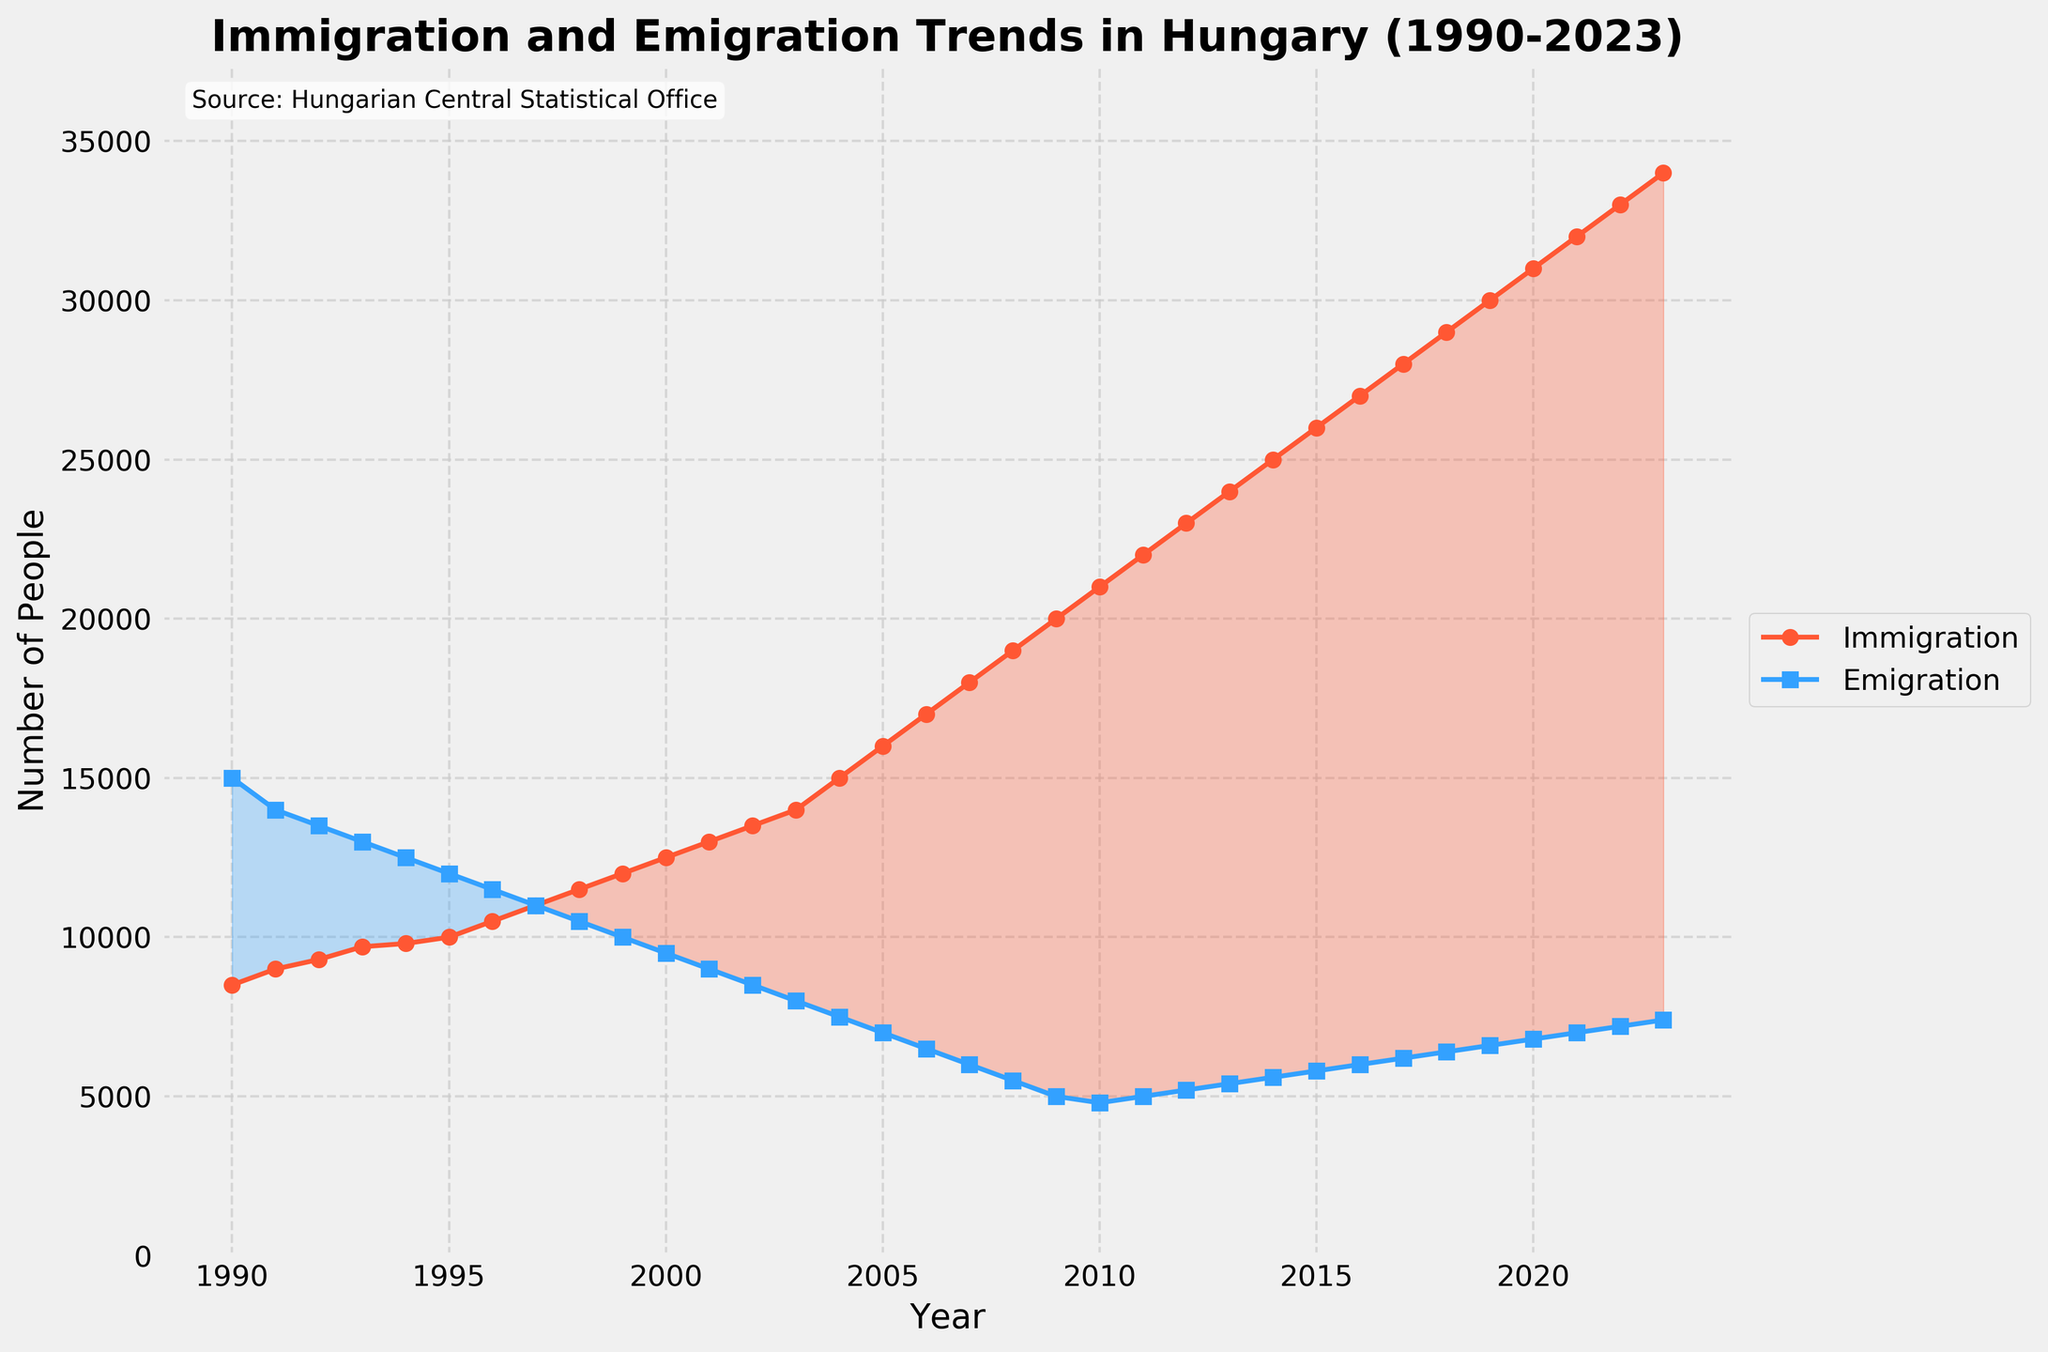How has the trend in immigration changed from 1990 to 2023? Observing the immigration line on the graph, it starts at 8500 in 1990 and shows a generally upward trend, ending at 34000 in 2023.
Answer: Increased How does the emigration trend compare to the immigration trend over the period? The emigration line starts higher than the immigration line at 15000 in 1990, but it declines over time, while the immigration line increases. By 2023, emigration has dropped to 7400, whereas immigration has risen to 34000.
Answer: Immigration increased, while emigration decreased What year did immigration surpass emigration significantly? By looking at the filled area between the two lines, we can see that immigration first notably surpassed emigration in the early 2000s, maintaining a higher trend onwards.
Answer: Early 2000s What is the approximate difference between immigration and emigration in 2023? The immigration value in 2023 is 34000, and the emigration value is 7400. Subtracting these gives 34000 - 7400 = 26600.
Answer: 26600 Which nationality group consistently had the highest number of migrants throughout the years? By examining the data provided for different nationalities, it's clear that Romania consistently had the highest number of migrants each year.
Answer: Romania In which year did the total number of migrants from countries other than Romania, Germany, Slovakia, and Ukraine peak? Referring to the values given for the "Nation_Other" category, the highest number is 10600 in 2023.
Answer: 2023 Between which two consecutive years did emigration see the largest decline? Comparing year-to-year values in the emigration column, the largest drop occurs between 2000 (9500) and 2001 (9000), a decline of 500.
Answer: 2000 to 2001 By how much did immigration exceed emigration on average over the period 2010 to 2023? First, calculate the difference for each year between 2010 and 2023, sum these differences, and then divide by the number of years (14):
[(21000-4800)+(22000-5000)+(23000-5200)+(24000-5400)+(25000-5600)+(26000-5800)+(27000-6000)+(28000-6200)+(29000-6400)+(30000-6600)+(31000-6800)+(32000-7000)+(33000-7200)+(34000-7400)]/14 = 148400/14 = 10600
Answer: 10600 How did the migration trends from Ukraine change over time? Ukraine's migration had an initial increase until around the 1990s, but after 2011, it gradually decreased, dropping from 1000 in 2011 to 300 by 2023.
Answer: Initially increased, then decreased When did the number of immigrants first reach 20000? The immigration line hits 20000 for the first time around the year 2009.
Answer: 2009 